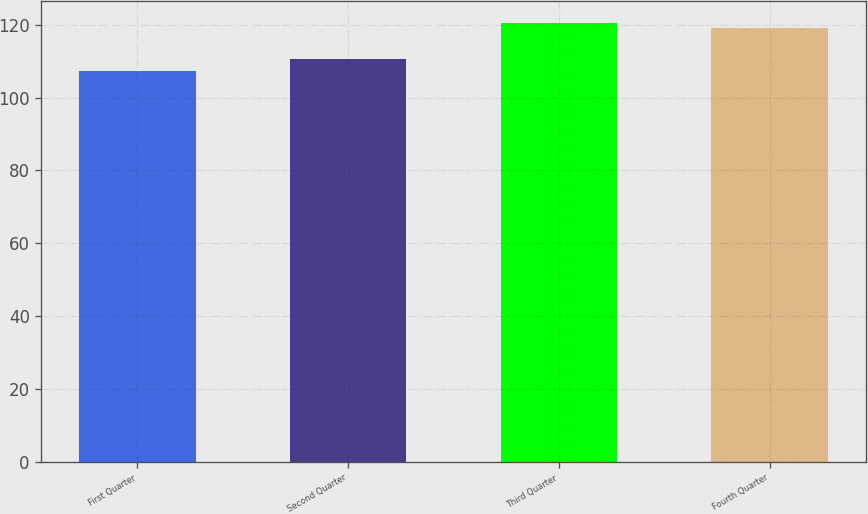Convert chart to OTSL. <chart><loc_0><loc_0><loc_500><loc_500><bar_chart><fcel>First Quarter<fcel>Second Quarter<fcel>Third Quarter<fcel>Fourth Quarter<nl><fcel>107.3<fcel>110.59<fcel>120.43<fcel>119.15<nl></chart> 